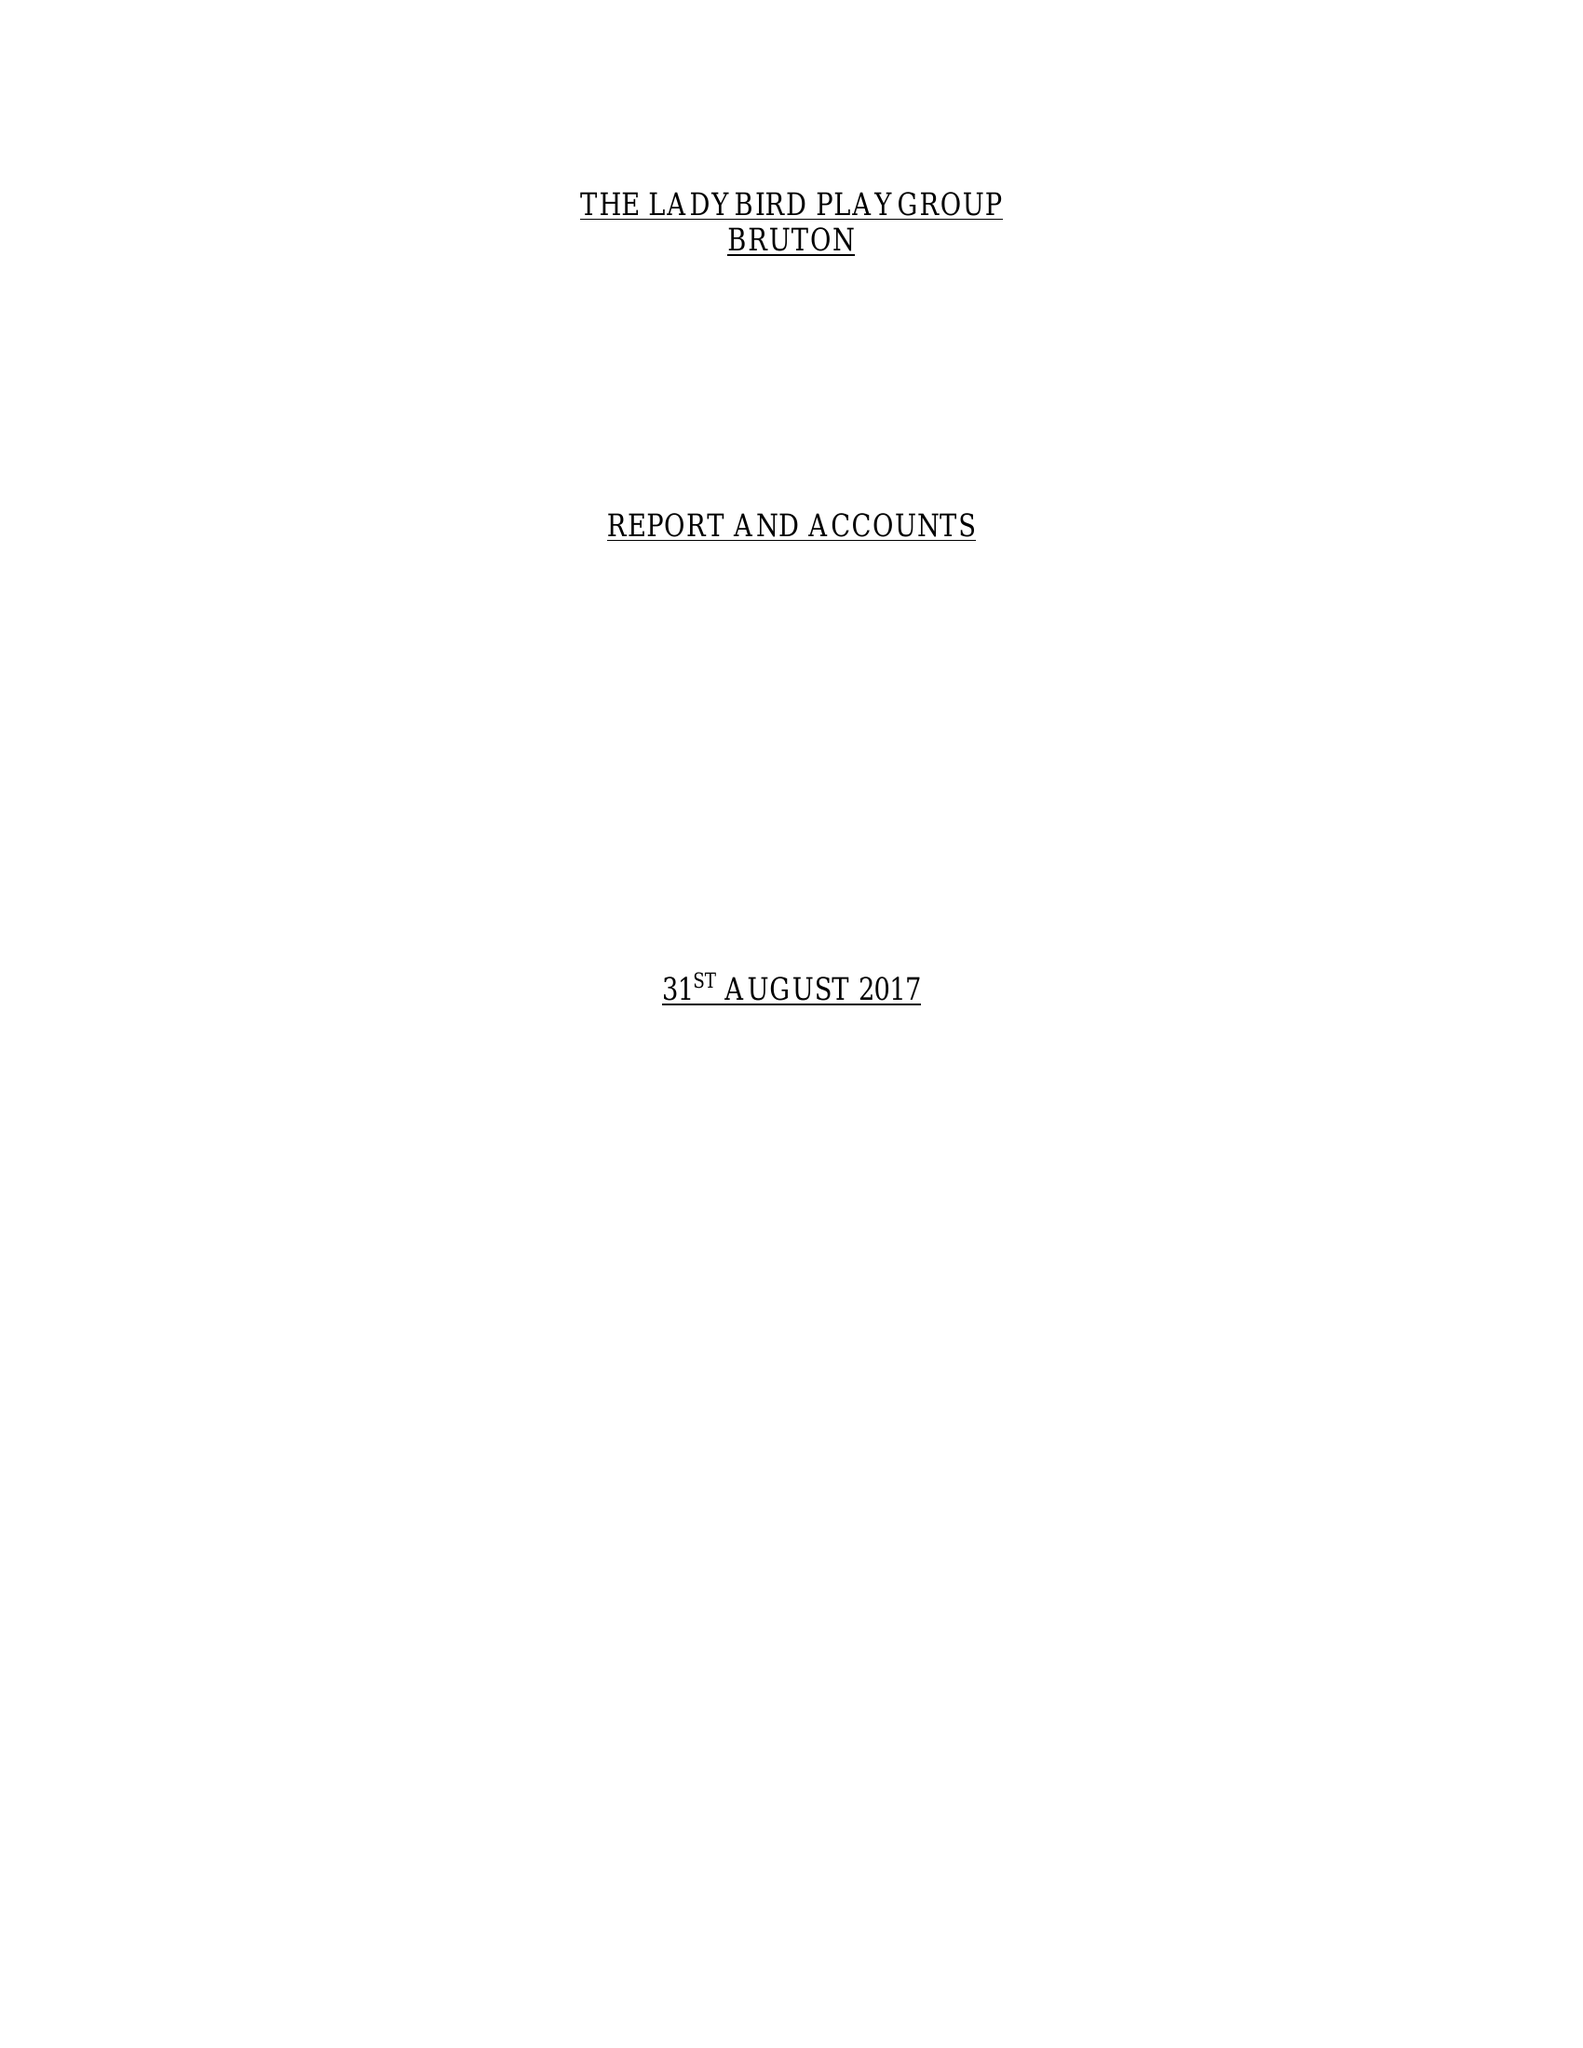What is the value for the income_annually_in_british_pounds?
Answer the question using a single word or phrase. 54655.00 